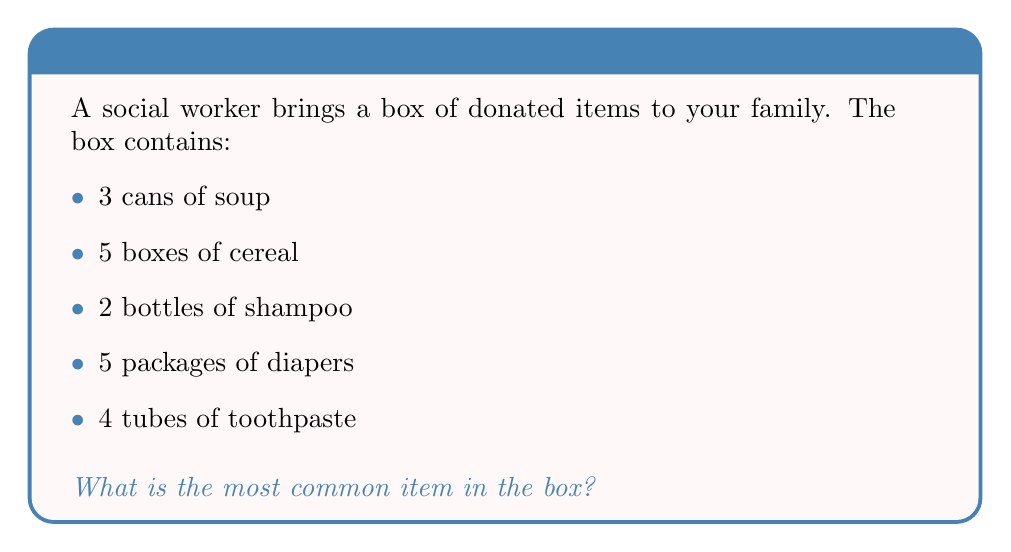Can you solve this math problem? To find the most common item in a set, we need to count the occurrences of each item and identify which one appears most frequently. Let's go through this step-by-step:

1. List all items and their quantities:
   - Soup: 3
   - Cereal: 5
   - Shampoo: 2
   - Diapers: 5
   - Toothpaste: 4

2. Identify the highest number of occurrences:
   The highest number we see is 5.

3. Check which items have this highest count:
   We can see that both cereal and diapers appear 5 times.

4. In case of a tie (as we have here), either item can be considered the most common.

Therefore, both cereal and diapers are the most common items in the box, appearing 5 times each.

In information theory, this concept relates to the idea of frequency distribution and entropy. The most common item(s) would have the highest probability in a probability distribution, which affects the overall entropy of the dataset.
Answer: Cereal or diapers 